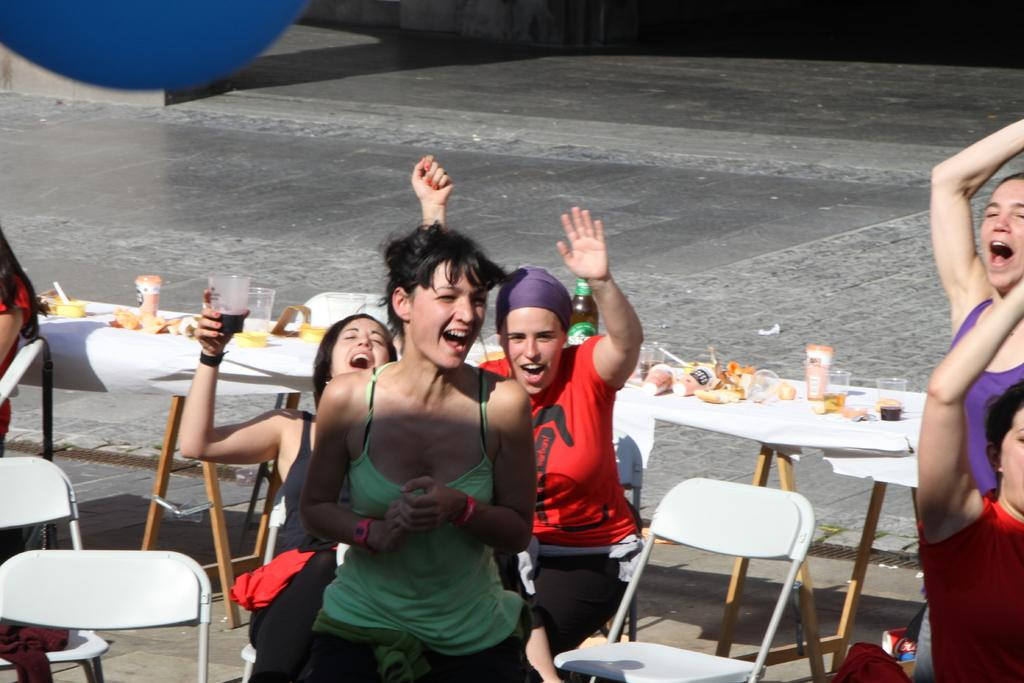How many people are in the image? There is a group of people in the image. What are some of the people doing in the image? Some people are seated on chairs, while others are standing. What is on the table in the image? Food items, glasses, and a bottle are present on the table. What type of brush is being used to paint the news on the wall in the image? There is no brush or news present in the image; it features a group of people, a table, and various items on the table. 